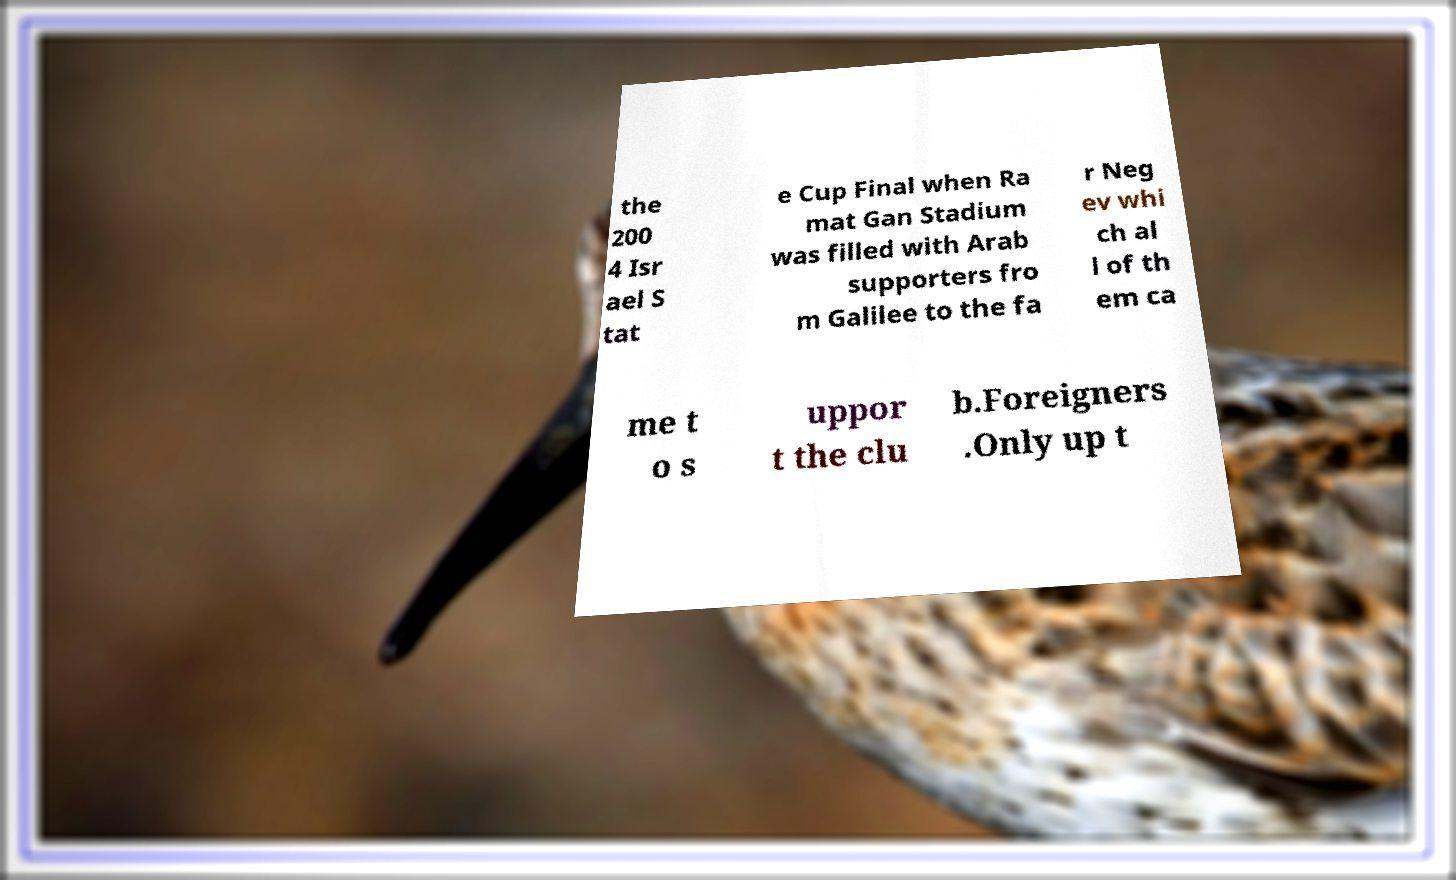Could you extract and type out the text from this image? the 200 4 Isr ael S tat e Cup Final when Ra mat Gan Stadium was filled with Arab supporters fro m Galilee to the fa r Neg ev whi ch al l of th em ca me t o s uppor t the clu b.Foreigners .Only up t 